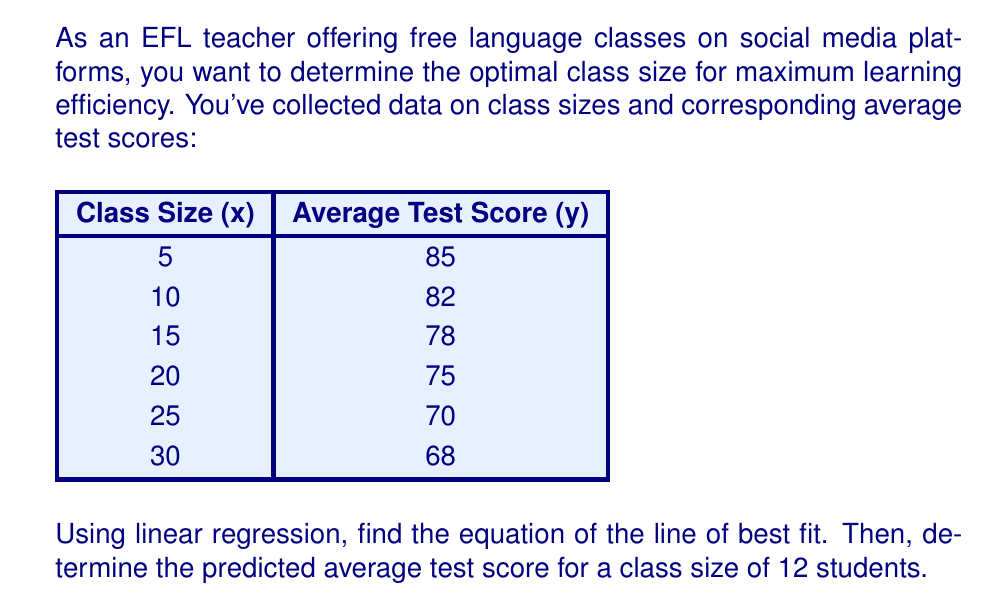Can you solve this math problem? To solve this problem, we'll use linear regression to find the line of best fit, then use that equation to predict the average test score for a class size of 12 students.

Step 1: Calculate the means of x and y
$\bar{x} = \frac{5 + 10 + 15 + 20 + 25 + 30}{6} = 17.5$
$\bar{y} = \frac{85 + 82 + 78 + 75 + 70 + 68}{6} = 76.33$

Step 2: Calculate the slope (m) using the formula:
$m = \frac{\sum(x - \bar{x})(y - \bar{y})}{\sum(x - \bar{x})^2}$

$\sum(x - \bar{x})(y - \bar{y}) = -437.5$
$\sum(x - \bar{x})^2 = 612.5$

$m = \frac{-437.5}{612.5} = -0.714$

Step 3: Calculate the y-intercept (b) using the formula:
$b = \bar{y} - m\bar{x}$
$b = 76.33 - (-0.714 \times 17.5) = 88.83$

Step 4: Write the equation of the line of best fit:
$y = mx + b$
$y = -0.714x + 88.83$

Step 5: Predict the average test score for a class size of 12 students:
$y = -0.714(12) + 88.83 = 80.26$

Therefore, the predicted average test score for a class size of 12 students is 80.26.
Answer: $y = -0.714x + 88.83$; 80.26 